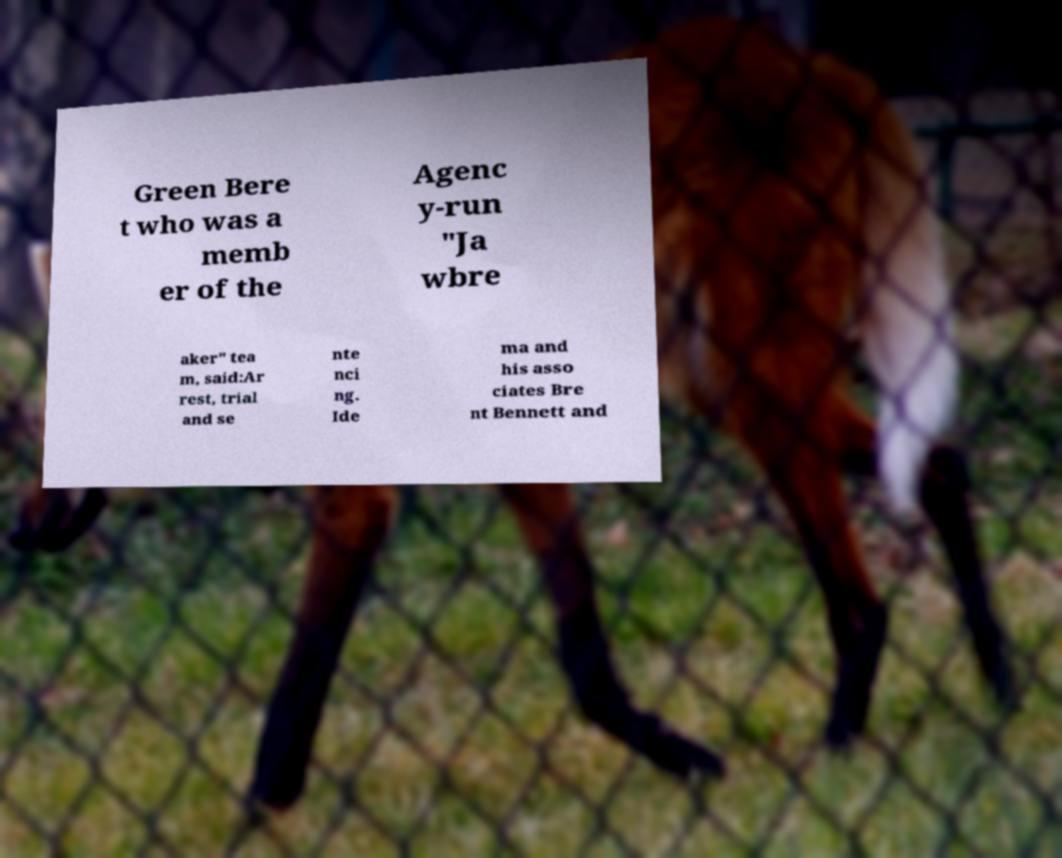What messages or text are displayed in this image? I need them in a readable, typed format. Green Bere t who was a memb er of the Agenc y-run "Ja wbre aker" tea m, said:Ar rest, trial and se nte nci ng. Ide ma and his asso ciates Bre nt Bennett and 